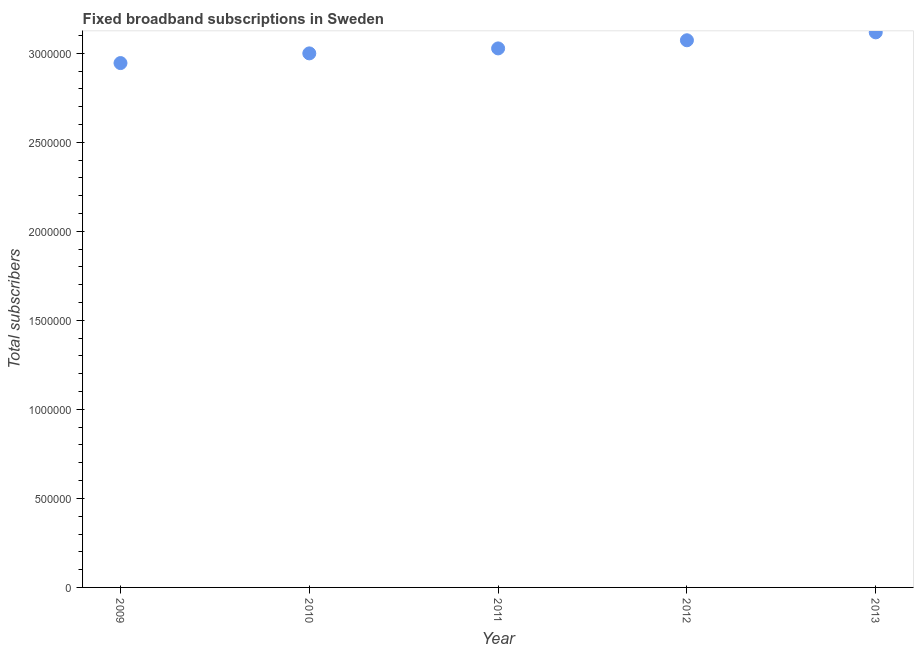What is the total number of fixed broadband subscriptions in 2010?
Give a very brief answer. 3.00e+06. Across all years, what is the maximum total number of fixed broadband subscriptions?
Your answer should be very brief. 3.12e+06. Across all years, what is the minimum total number of fixed broadband subscriptions?
Make the answer very short. 2.95e+06. In which year was the total number of fixed broadband subscriptions minimum?
Give a very brief answer. 2009. What is the sum of the total number of fixed broadband subscriptions?
Provide a succinct answer. 1.52e+07. What is the difference between the total number of fixed broadband subscriptions in 2009 and 2012?
Offer a terse response. -1.28e+05. What is the average total number of fixed broadband subscriptions per year?
Your answer should be very brief. 3.03e+06. What is the median total number of fixed broadband subscriptions?
Your answer should be compact. 3.03e+06. In how many years, is the total number of fixed broadband subscriptions greater than 2800000 ?
Offer a terse response. 5. Do a majority of the years between 2011 and 2010 (inclusive) have total number of fixed broadband subscriptions greater than 300000 ?
Provide a succinct answer. No. What is the ratio of the total number of fixed broadband subscriptions in 2010 to that in 2012?
Make the answer very short. 0.98. Is the difference between the total number of fixed broadband subscriptions in 2011 and 2013 greater than the difference between any two years?
Your response must be concise. No. What is the difference between the highest and the second highest total number of fixed broadband subscriptions?
Provide a succinct answer. 4.44e+04. What is the difference between the highest and the lowest total number of fixed broadband subscriptions?
Ensure brevity in your answer.  1.73e+05. How many years are there in the graph?
Provide a succinct answer. 5. What is the difference between two consecutive major ticks on the Y-axis?
Provide a succinct answer. 5.00e+05. Are the values on the major ticks of Y-axis written in scientific E-notation?
Provide a succinct answer. No. Does the graph contain any zero values?
Give a very brief answer. No. Does the graph contain grids?
Your answer should be compact. No. What is the title of the graph?
Ensure brevity in your answer.  Fixed broadband subscriptions in Sweden. What is the label or title of the Y-axis?
Give a very brief answer. Total subscribers. What is the Total subscribers in 2009?
Give a very brief answer. 2.95e+06. What is the Total subscribers in 2010?
Provide a succinct answer. 3.00e+06. What is the Total subscribers in 2011?
Your response must be concise. 3.03e+06. What is the Total subscribers in 2012?
Your answer should be very brief. 3.07e+06. What is the Total subscribers in 2013?
Your response must be concise. 3.12e+06. What is the difference between the Total subscribers in 2009 and 2010?
Your response must be concise. -5.44e+04. What is the difference between the Total subscribers in 2009 and 2011?
Keep it short and to the point. -8.24e+04. What is the difference between the Total subscribers in 2009 and 2012?
Your response must be concise. -1.28e+05. What is the difference between the Total subscribers in 2009 and 2013?
Give a very brief answer. -1.73e+05. What is the difference between the Total subscribers in 2010 and 2011?
Your answer should be very brief. -2.79e+04. What is the difference between the Total subscribers in 2010 and 2012?
Provide a succinct answer. -7.36e+04. What is the difference between the Total subscribers in 2010 and 2013?
Your answer should be very brief. -1.18e+05. What is the difference between the Total subscribers in 2011 and 2012?
Make the answer very short. -4.57e+04. What is the difference between the Total subscribers in 2011 and 2013?
Make the answer very short. -9.01e+04. What is the difference between the Total subscribers in 2012 and 2013?
Your answer should be very brief. -4.44e+04. What is the ratio of the Total subscribers in 2009 to that in 2012?
Give a very brief answer. 0.96. What is the ratio of the Total subscribers in 2009 to that in 2013?
Offer a very short reply. 0.94. What is the ratio of the Total subscribers in 2011 to that in 2013?
Ensure brevity in your answer.  0.97. What is the ratio of the Total subscribers in 2012 to that in 2013?
Give a very brief answer. 0.99. 